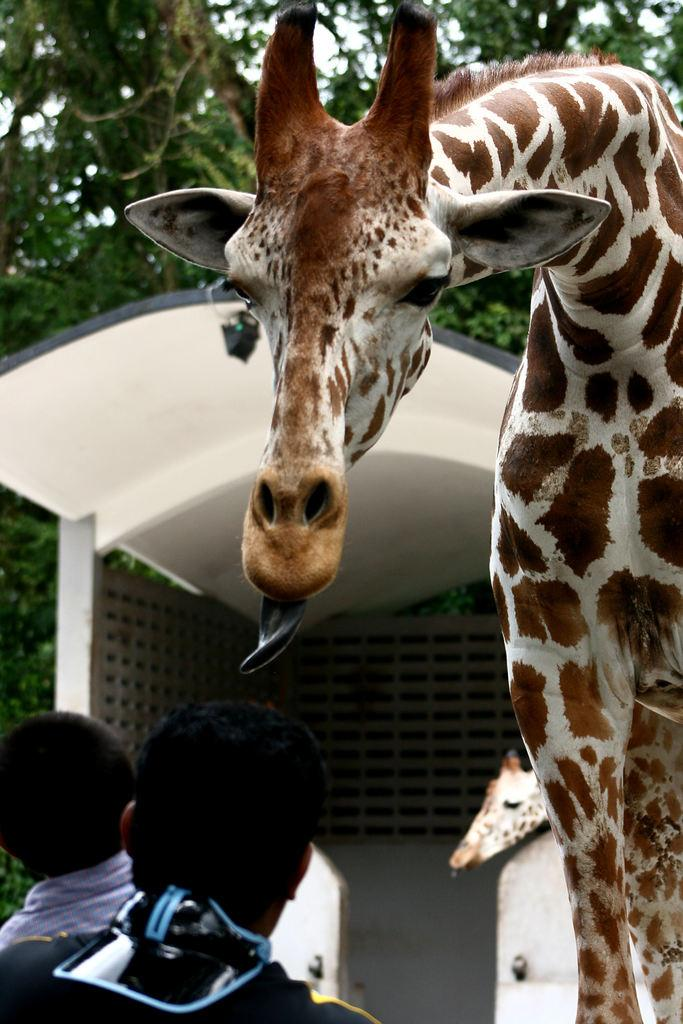What type of animal is standing in the image? There is a giraffe standing in the image. How many people are present in the image? There are two persons standing in the image. What structure can be seen in the image? There is a shed construction in the image. What can be seen in the background of the image? There are trees visible in the background of the image. Where is the chair located in the image? There is no chair present in the image. What type of tub is visible in the image? There is no tub present in the image. 